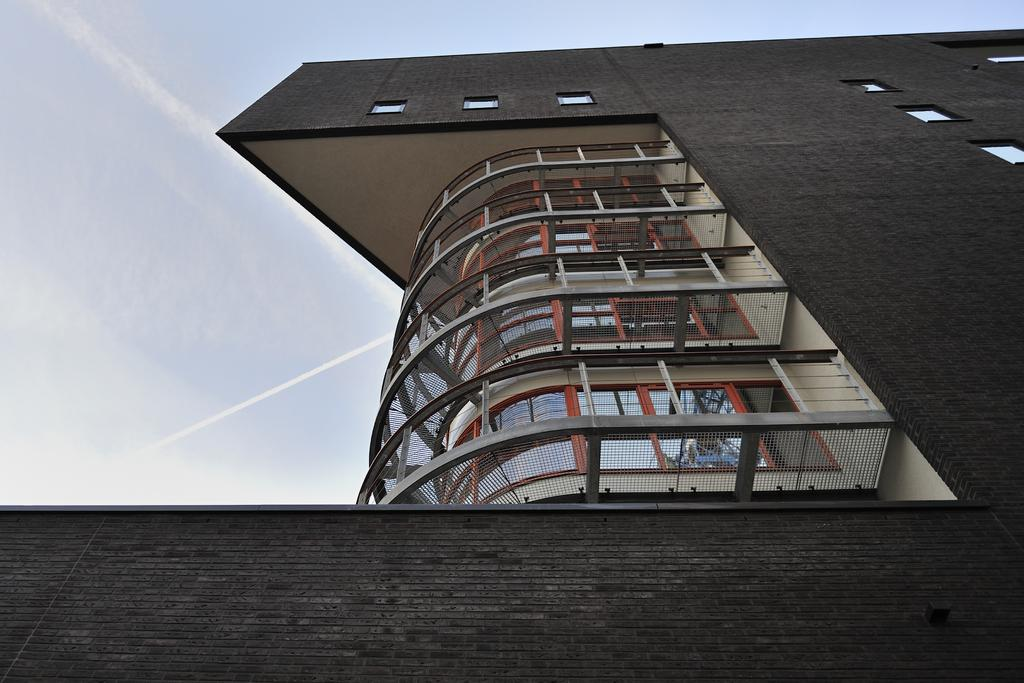What type of structure can be seen in the image? There is a building in the image. What can be seen in the sky in the image? There are clouds visible in the sky in the image. What type of teeth can be seen on the building in the image? There are no teeth present on the building in the image. 